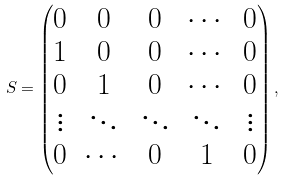<formula> <loc_0><loc_0><loc_500><loc_500>S = \begin{pmatrix} 0 & 0 & 0 & \cdots & 0 \\ 1 & 0 & 0 & \cdots & 0 \\ 0 & 1 & 0 & \cdots & 0 \\ \vdots & \ddots & \ddots & \ddots & \vdots \\ 0 & \cdots & 0 & 1 & 0 \\ \end{pmatrix} ,</formula> 